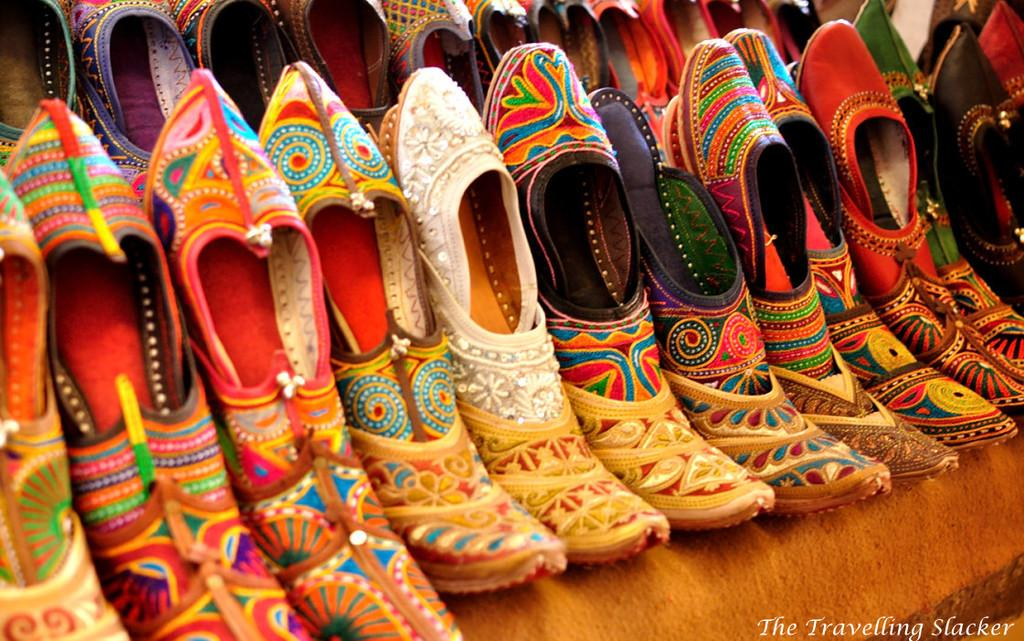What types of objects can be seen in the image? There are multiple footwear in the image. Can you describe any additional features of the image? There is a watermark in the bottom right side of the image. What type of ring can be seen on the stone in the image? There is no ring or stone present in the image; it only features multiple footwear and a watermark. 